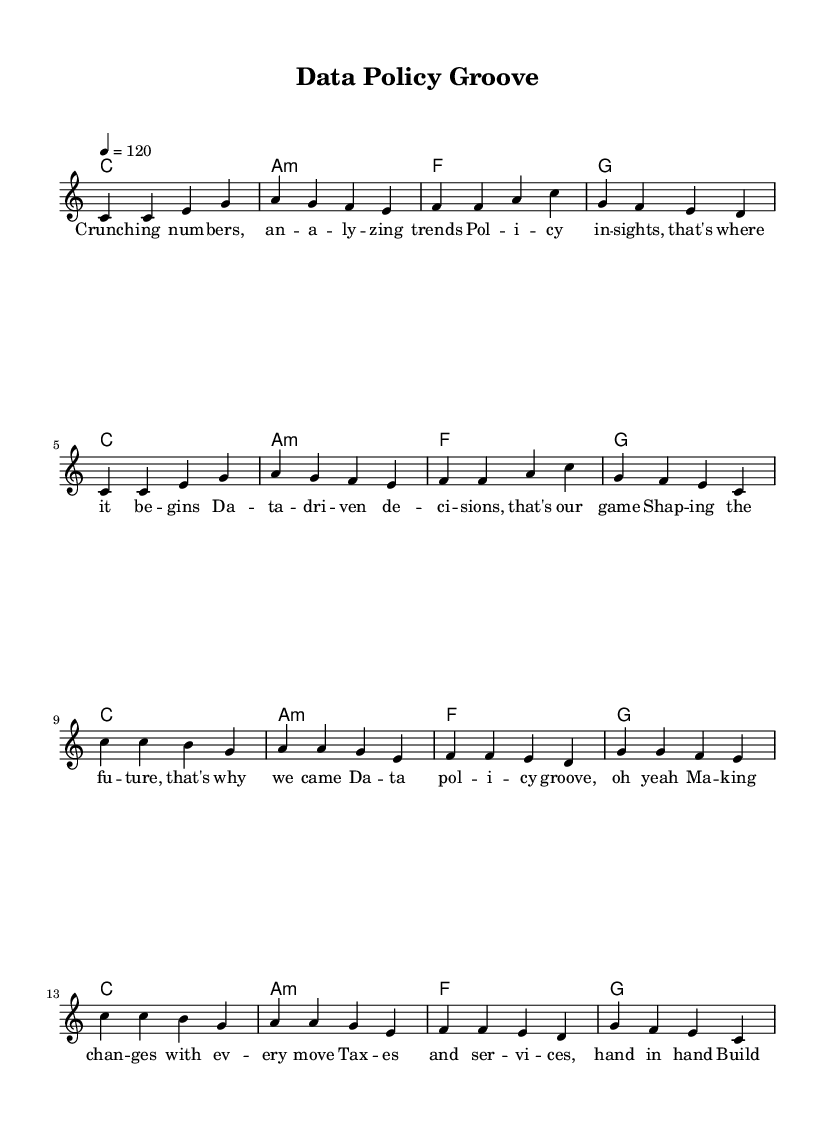What is the key signature of this music? The key signature is indicated at the beginning of the piece and signifies C major, which has no sharps or flats.
Answer: C major What is the time signature of this music? The time signature is shown just after the key signature and is written as 4/4, meaning there are four beats in each measure and a quarter note receives one beat.
Answer: 4/4 What is the tempo marking of this music? The tempo marking is located near the top of the sheet music, indicated as 4 = 120, which tells us to play quarter notes at a speed of 120 beats per minute.
Answer: 120 How many measures are in the verse section? By counting the bars in the melody under the verse section, we see there are 8 measures in total, as indicated by each vertical line dividing the music.
Answer: 8 What is the emotional theme of the lyrics in this song? The lyrics focus on data analysis and policy-making, emphasizing themes of decision-making, change, and building a better future. The repeated phrases in the chorus enhance this emotional connection.
Answer: Change What type of chords are primarily used in this music? The chord progression mainly consists of major and minor chords, specifically utilizing triads formed by the root, third, and fifth notes of the scale, which are common in pop music for creating a catchy sound.
Answer: Major and minor Which section contains the repetitive lyrical phrase? The chorus contains the repetitive lyrical phrases, commonly found in pop music to make the song catchy and memorable, reinforcing the core message of the song.
Answer: Chorus 